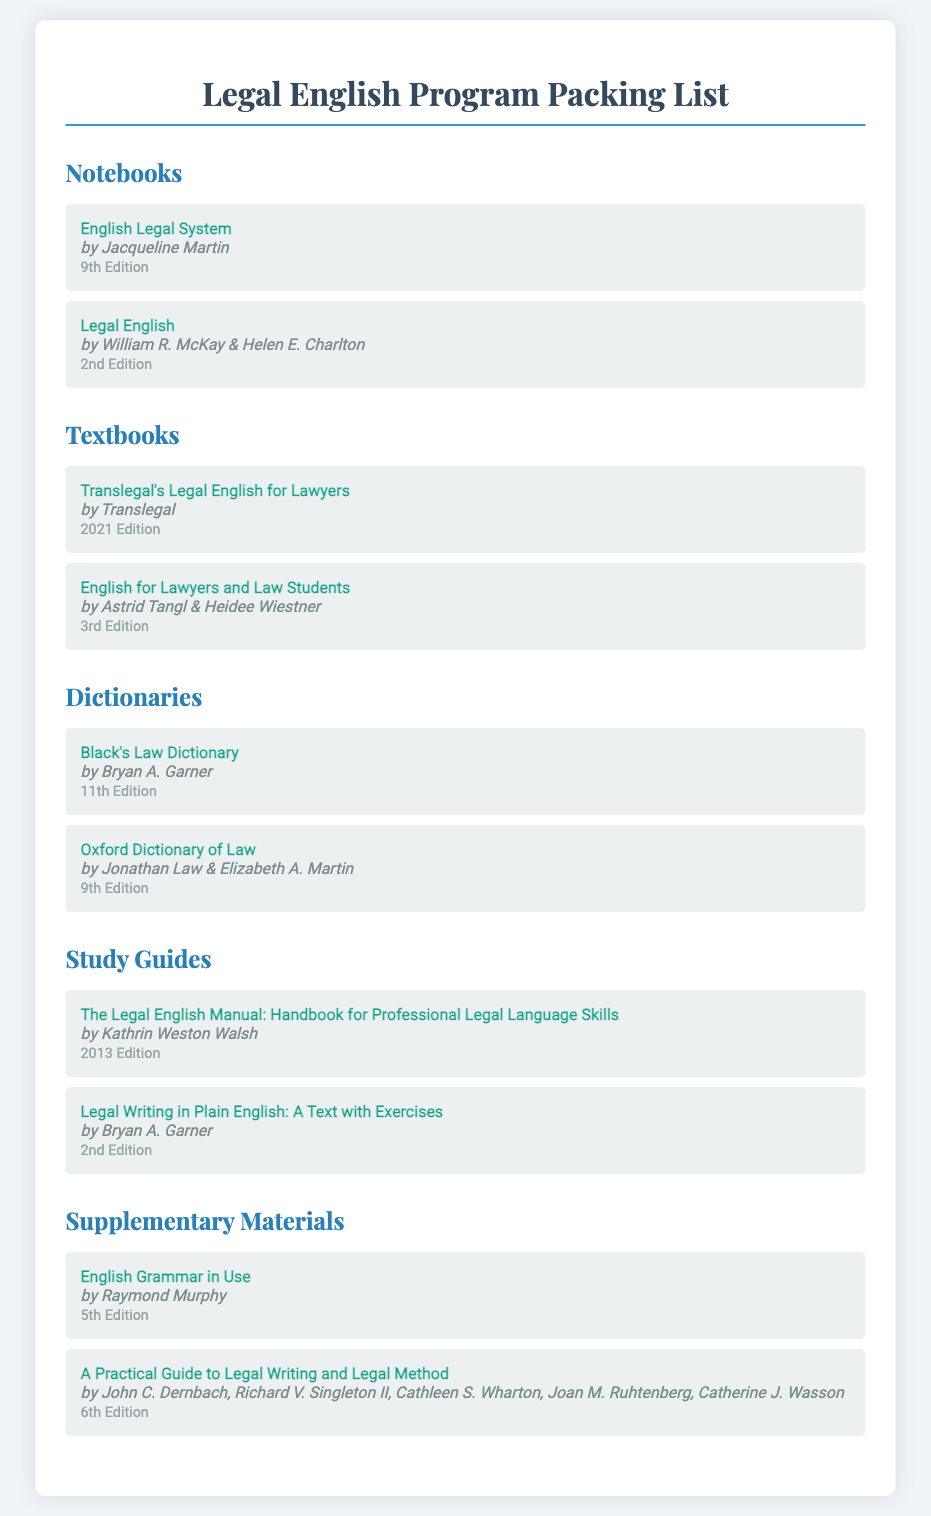what is the title of the first notebook? The title of the first notebook is found in the Notebooks section and is "English Legal System."
Answer: English Legal System who is the author of "Legal English"? The author of "Legal English" is listed in the Notebooks section.
Answer: William R. McKay & Helen E. Charlton which edition of Black's Law Dictionary is mentioned? The edition of Black's Law Dictionary is specified in the Dictionaries section.
Answer: 11th Edition how many textbooks are listed in the document? The total number of textbooks can be counted in the Textbooks section.
Answer: 2 what is the publication year of Translegal's Legal English for Lawyers? The publication year of Translegal's Legal English for Lawyers is provided in the Textbooks section.
Answer: 2021 Edition which section contains study guides? The section that contains study guides is clearly mentioned.
Answer: Study Guides name one author of a supplementary material. An author of a supplementary material can be found in the Supplementary Materials section.
Answer: Raymond Murphy which two types of materials are listed in the document? The materials listed in the document can be categorized as titles under different sections.
Answer: Notebooks, Textbooks what is the last book title mentioned in the supplementary materials? The last book title in the Supplementary Materials section is noted.
Answer: A Practical Guide to Legal Writing and Legal Method 